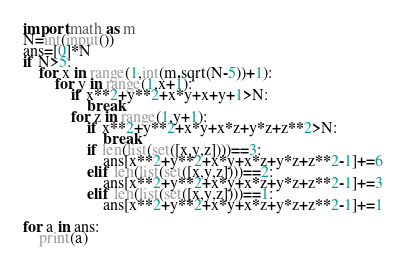<code> <loc_0><loc_0><loc_500><loc_500><_Python_>import math as m
N=int(input())
ans=[0]*N
if N>5:
    for x in range(1,int(m.sqrt(N-5))+1):
        for y in range(1,x+1):
            if x**2+y**2+x*y+x+y+1>N:
                break
            for z in range(1,y+1):
                if x**2+y**2+x*y+x*z+y*z+z**2>N:
                    break
                if len(list(set([x,y,z])))==3:
                    ans[x**2+y**2+x*y+x*z+y*z+z**2-1]+=6
                elif len(list(set([x,y,z])))==2:
                    ans[x**2+y**2+x*y+x*z+y*z+z**2-1]+=3
                elif len(list(set([x,y,z])))==1:
                    ans[x**2+y**2+x*y+x*z+y*z+z**2-1]+=1

for a in ans:
    print(a)
</code> 